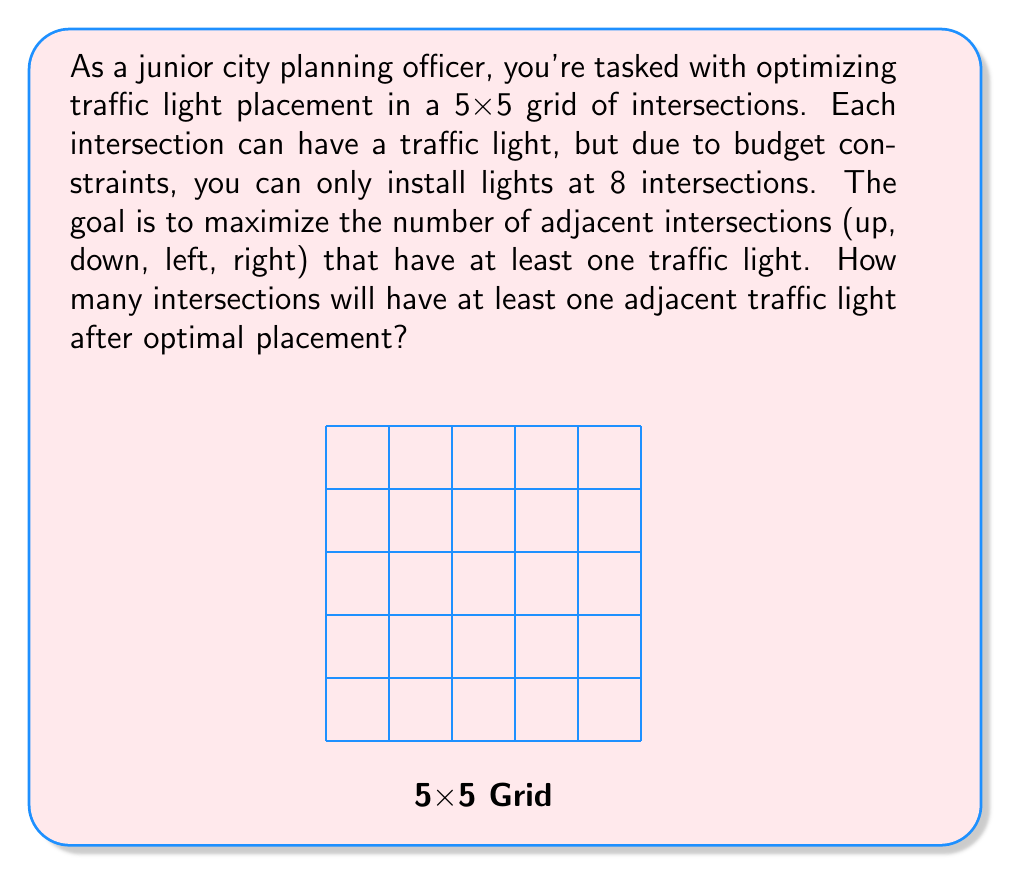Provide a solution to this math problem. Let's approach this step-by-step:

1) First, we need to understand that corner intersections can only affect 2 adjacent intersections, edge intersections can affect 3, and central intersections can affect 4.

2) To maximize coverage, we should prioritize central intersections. However, we need to ensure we don't place lights too close together, as that would waste coverage.

3) The optimal placement would be:

[asy]
unitsize(1cm);
for(int i=0; i<6; ++i) {
  draw((0,i)--(5,i));
  draw((i,0)--(i,5));
}
dot((1,1), red);
dot((1,3), red);
dot((3,1), red);
dot((3,3), red);
dot((1,5), red);
dot((3,5), red);
dot((5,1), red);
dot((5,3), red);
label("Traffic Light", (6,2.5), E);
[/asy]

4) Let's count the covered intersections:
   - Each central light (4) covers 4 intersections: $4 * 4 = 16$
   - Each edge light (4) covers 3 intersections: $4 * 3 = 12$
   - However, some intersections are covered by multiple lights

5) To get the total unique covered intersections:
   - All intersections except the corners and the center are covered
   - Total intersections: $5 * 5 = 25$
   - Uncovered corners: 4
   - Uncovered center: 1
   - Covered intersections: $25 - 4 - 1 = 20$

Therefore, 20 intersections will have at least one adjacent traffic light after optimal placement.
Answer: 20 intersections 